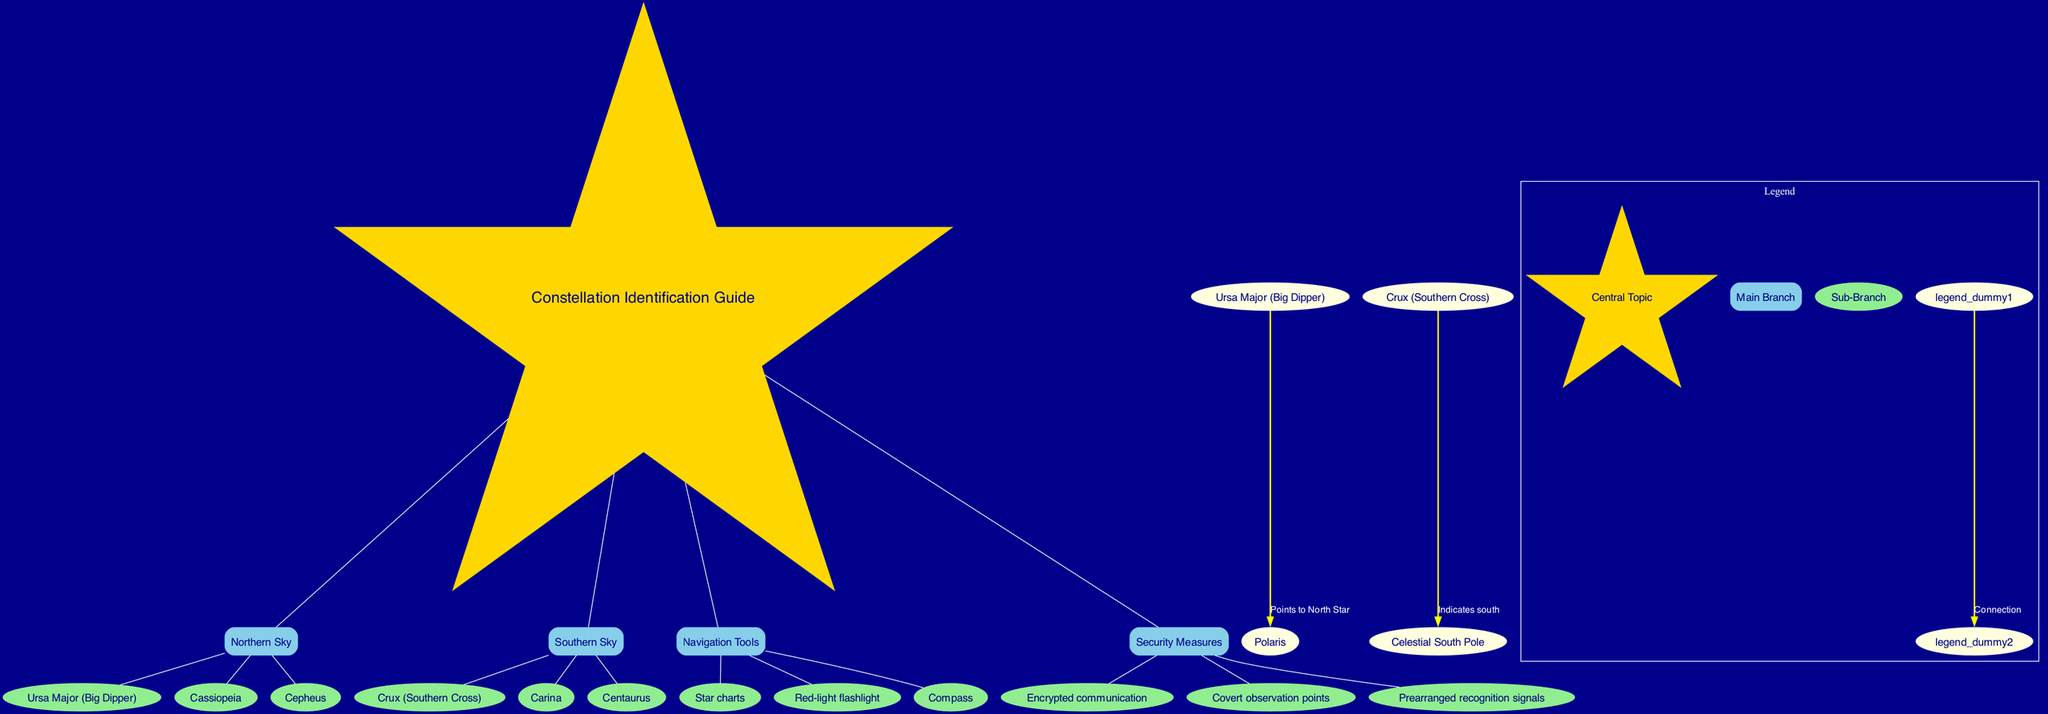What are the three main branches in the diagram? The diagram's main branches are listed under the "main_branches" key. They are "Northern Sky," "Southern Sky," "Navigation Tools," and "Security Measures."
Answer: Northern Sky, Southern Sky, Navigation Tools, Security Measures Which constellation points to the North Star? The relationship between constellations and their navigation function is established via the "connections" section. Here, "Ursa Major (Big Dipper)" is indicated to point to "Polaris," which is the North Star.
Answer: Ursa Major (Big Dipper) How many sub-branches are under "Southern Sky"? By counting the entries listed in the "sub_branches" of "Southern Sky," we see there are three: "Crux (Southern Cross)," "Carina," and "Centaurus."
Answer: 3 What measures are listed for security in the diagram? The diagram indicates measures under the "Security Measures" node. They include "Encrypted communication," "Covert observation points," and "Prearranged recognition signals."
Answer: Encrypted communication, Covert observation points, Prearranged recognition signals Which constellation indicates south? The connections in the diagram show that "Crux (Southern Cross)" directly indicates the "Celestial South Pole," therefore it is the constellation that indicates south.
Answer: Crux (Southern Cross) What navigation tool is represented in the diagram? The "Navigation Tools" branch includes "Star charts," "Red-light flashlight," and "Compass." By reviewing the sub-branches, we identify these three navigation tools.
Answer: Star charts, Red-light flashlight, Compass How does the "Northern Sky" relate to navigation? The "Northern Sky" branch contains constellations that assist in navigation by allowing the identification of the North Star and direction. "Ursa Major (Big Dipper)" helps to locate "Polaris," which is crucial for navigational purposes.
Answer: Locates Polaris List one connection made in the diagram. In the connections section, one specific relationship noted is that "Crux (Southern Cross)" points to the "Celestial South Pole," indicating a direct navigational aid.
Answer: Crux (Southern Cross) to Celestial South Pole 